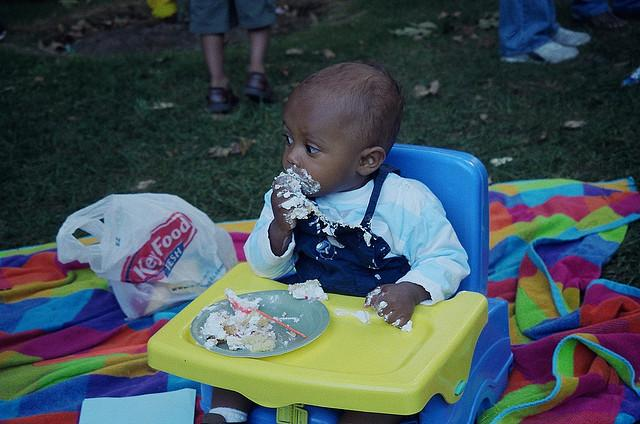Why is this person so messy? Please explain your reasoning. baby. The little tyke doesn't even know he's being messy. 